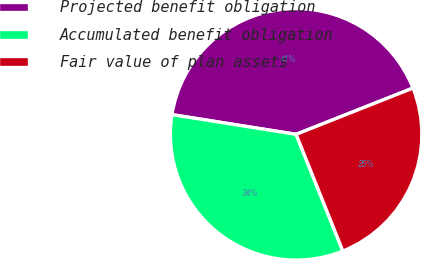Convert chart to OTSL. <chart><loc_0><loc_0><loc_500><loc_500><pie_chart><fcel>Projected benefit obligation<fcel>Accumulated benefit obligation<fcel>Fair value of plan assets<nl><fcel>41.49%<fcel>33.57%<fcel>24.94%<nl></chart> 